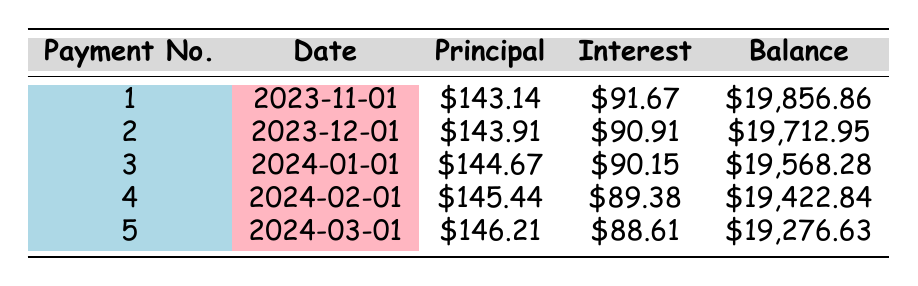What is the total loan amount borrowed by Alex Johnson? The loan details specify that the loan amount is directly listed as 20000.
Answer: 20000 What is the monthly payment amount Alex has to make? The loan details indicate that the monthly payment is clearly stated as 215.06.
Answer: 215.06 How much interest is paid in the first payment? The first row of the amortization schedule shows that the interest payment for the first payment number is 91.67.
Answer: 91.67 Is the principal payment in the second month greater than in the first month? The principal payment for the first month is 143.14, and for the second month, it is 143.91, which is greater.
Answer: Yes What is the total interest paid over the life of the loan? The loan details state that the total interest paid is 5807.20.
Answer: 5807.20 What is the remaining balance after the fifth payment? In the amortization schedule, the remaining balance after the fifth payment is listed as 19276.63.
Answer: 19276.63 What is the difference in interest paid between the first and second payment? The interest paid in the first payment is 91.67, and in the second payment is 90.91. Thus, the difference is 91.67 - 90.91 = 0.76.
Answer: 0.76 How many payments are made before the remaining balance goes below 20000? The initial loan balance is 20000, and the remaining balance after the first payment is already below 20000 (19856.86), so the answer is one payment.
Answer: 1 What is the average principal payment over the first five months? The principal payments for the first five months are 143.14, 143.91, 144.67, 145.44, and 146.21. The total is 718.37, and dividing this by 5 gives an average of 143.674. This rounds to 143.67.
Answer: 143.67 